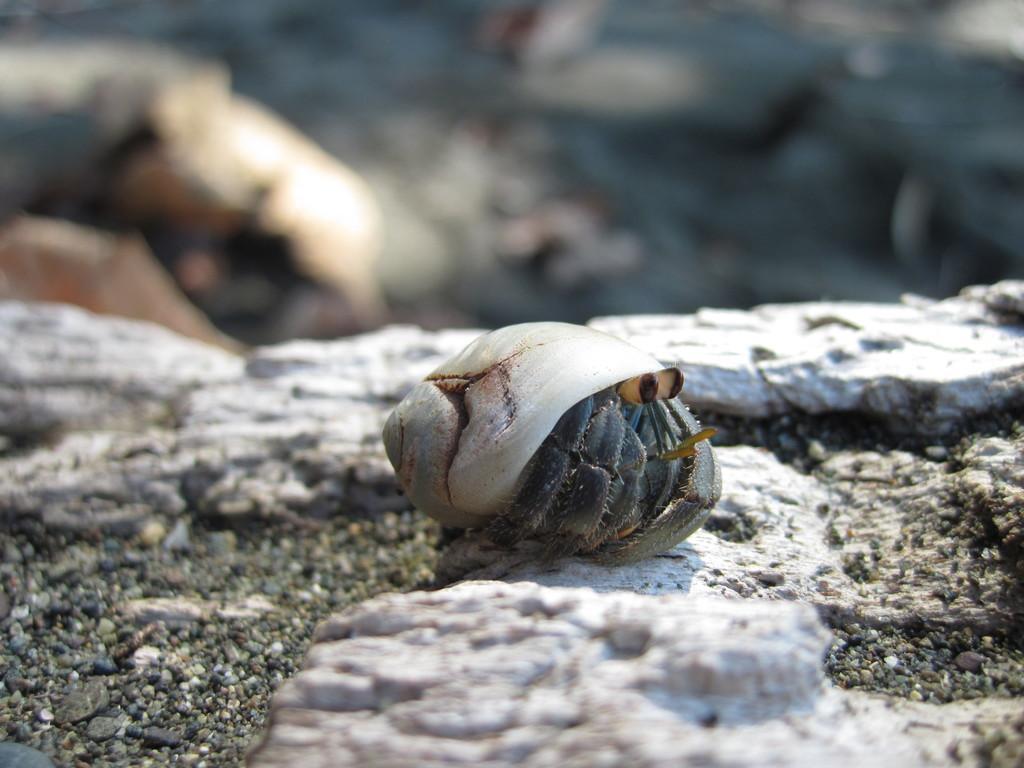How would you summarize this image in a sentence or two? In this image I can see a conch on the stone. In the background, I can see the image is blurred. 